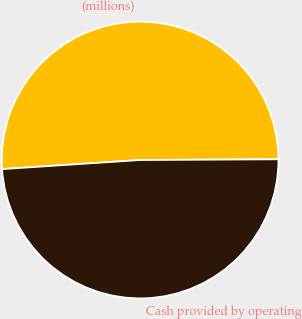<chart> <loc_0><loc_0><loc_500><loc_500><pie_chart><fcel>(millions)<fcel>Cash provided by operating<nl><fcel>50.96%<fcel>49.04%<nl></chart> 